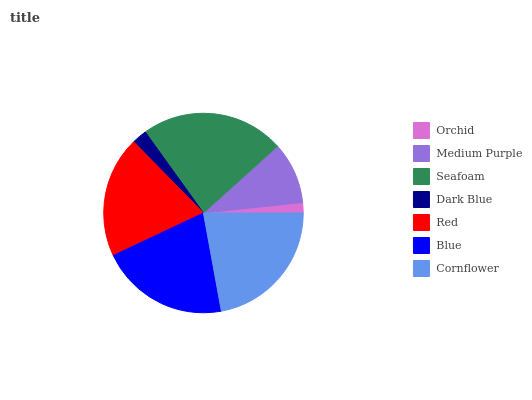Is Orchid the minimum?
Answer yes or no. Yes. Is Seafoam the maximum?
Answer yes or no. Yes. Is Medium Purple the minimum?
Answer yes or no. No. Is Medium Purple the maximum?
Answer yes or no. No. Is Medium Purple greater than Orchid?
Answer yes or no. Yes. Is Orchid less than Medium Purple?
Answer yes or no. Yes. Is Orchid greater than Medium Purple?
Answer yes or no. No. Is Medium Purple less than Orchid?
Answer yes or no. No. Is Red the high median?
Answer yes or no. Yes. Is Red the low median?
Answer yes or no. Yes. Is Seafoam the high median?
Answer yes or no. No. Is Dark Blue the low median?
Answer yes or no. No. 